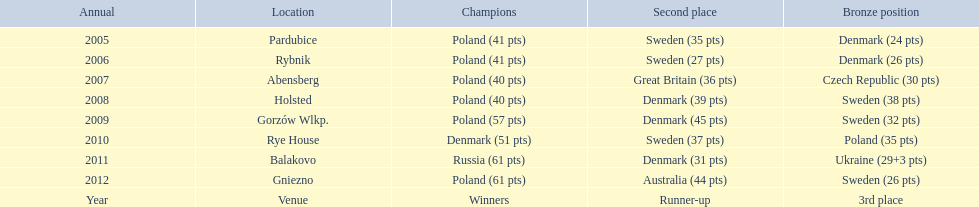Did holland win the 2010 championship? if not who did? Rye House. What did position did holland they rank? 3rd place. 